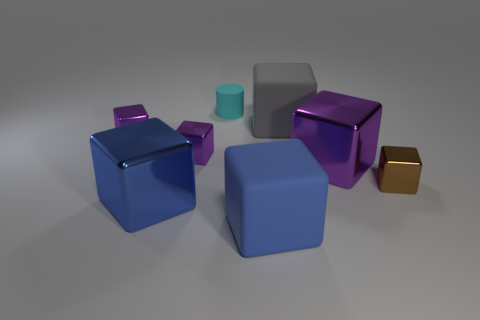Are there any other things that have the same shape as the cyan object?
Ensure brevity in your answer.  No. Is the material of the big purple object the same as the brown thing?
Provide a short and direct response. Yes. There is a matte object that is both in front of the cyan matte thing and to the left of the gray rubber block; how big is it?
Your answer should be compact. Large. What is the shape of the blue rubber thing?
Your answer should be very brief. Cube. How many objects are large matte objects or things that are to the left of the tiny brown block?
Your answer should be compact. 7. What color is the block that is on the left side of the brown metallic thing and right of the gray object?
Give a very brief answer. Purple. There is a big blue cube to the right of the cyan rubber cylinder; what is its material?
Offer a terse response. Rubber. The blue metallic block has what size?
Make the answer very short. Large. How many cyan objects are small metallic cubes or big matte cubes?
Your answer should be very brief. 0. There is a blue cube that is behind the blue block right of the small cyan thing; what is its size?
Keep it short and to the point. Large. 